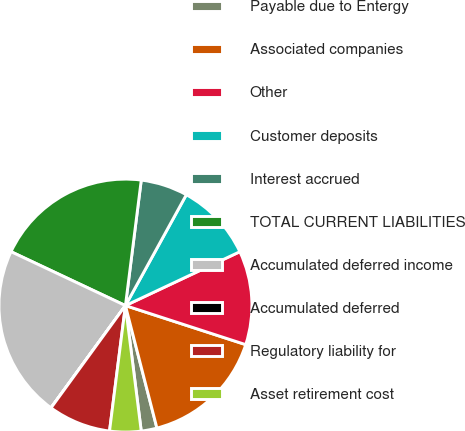Convert chart. <chart><loc_0><loc_0><loc_500><loc_500><pie_chart><fcel>Payable due to Entergy<fcel>Associated companies<fcel>Other<fcel>Customer deposits<fcel>Interest accrued<fcel>TOTAL CURRENT LIABILITIES<fcel>Accumulated deferred income<fcel>Accumulated deferred<fcel>Regulatory liability for<fcel>Asset retirement cost<nl><fcel>2.01%<fcel>16.0%<fcel>12.0%<fcel>10.0%<fcel>6.0%<fcel>19.99%<fcel>21.99%<fcel>0.01%<fcel>8.0%<fcel>4.0%<nl></chart> 